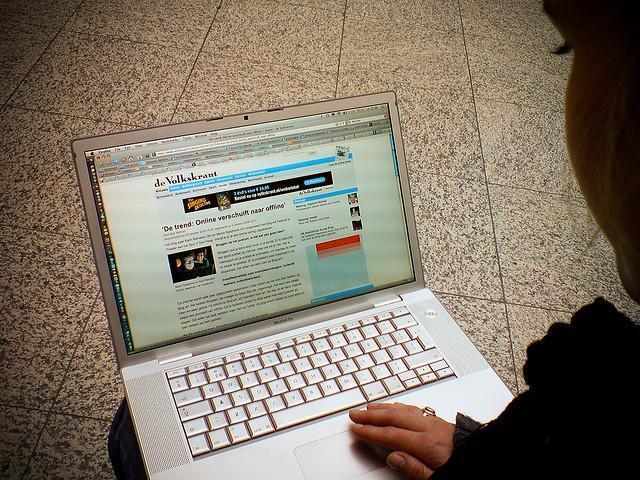How many windows are open on the monitor?
Give a very brief answer. 1. 